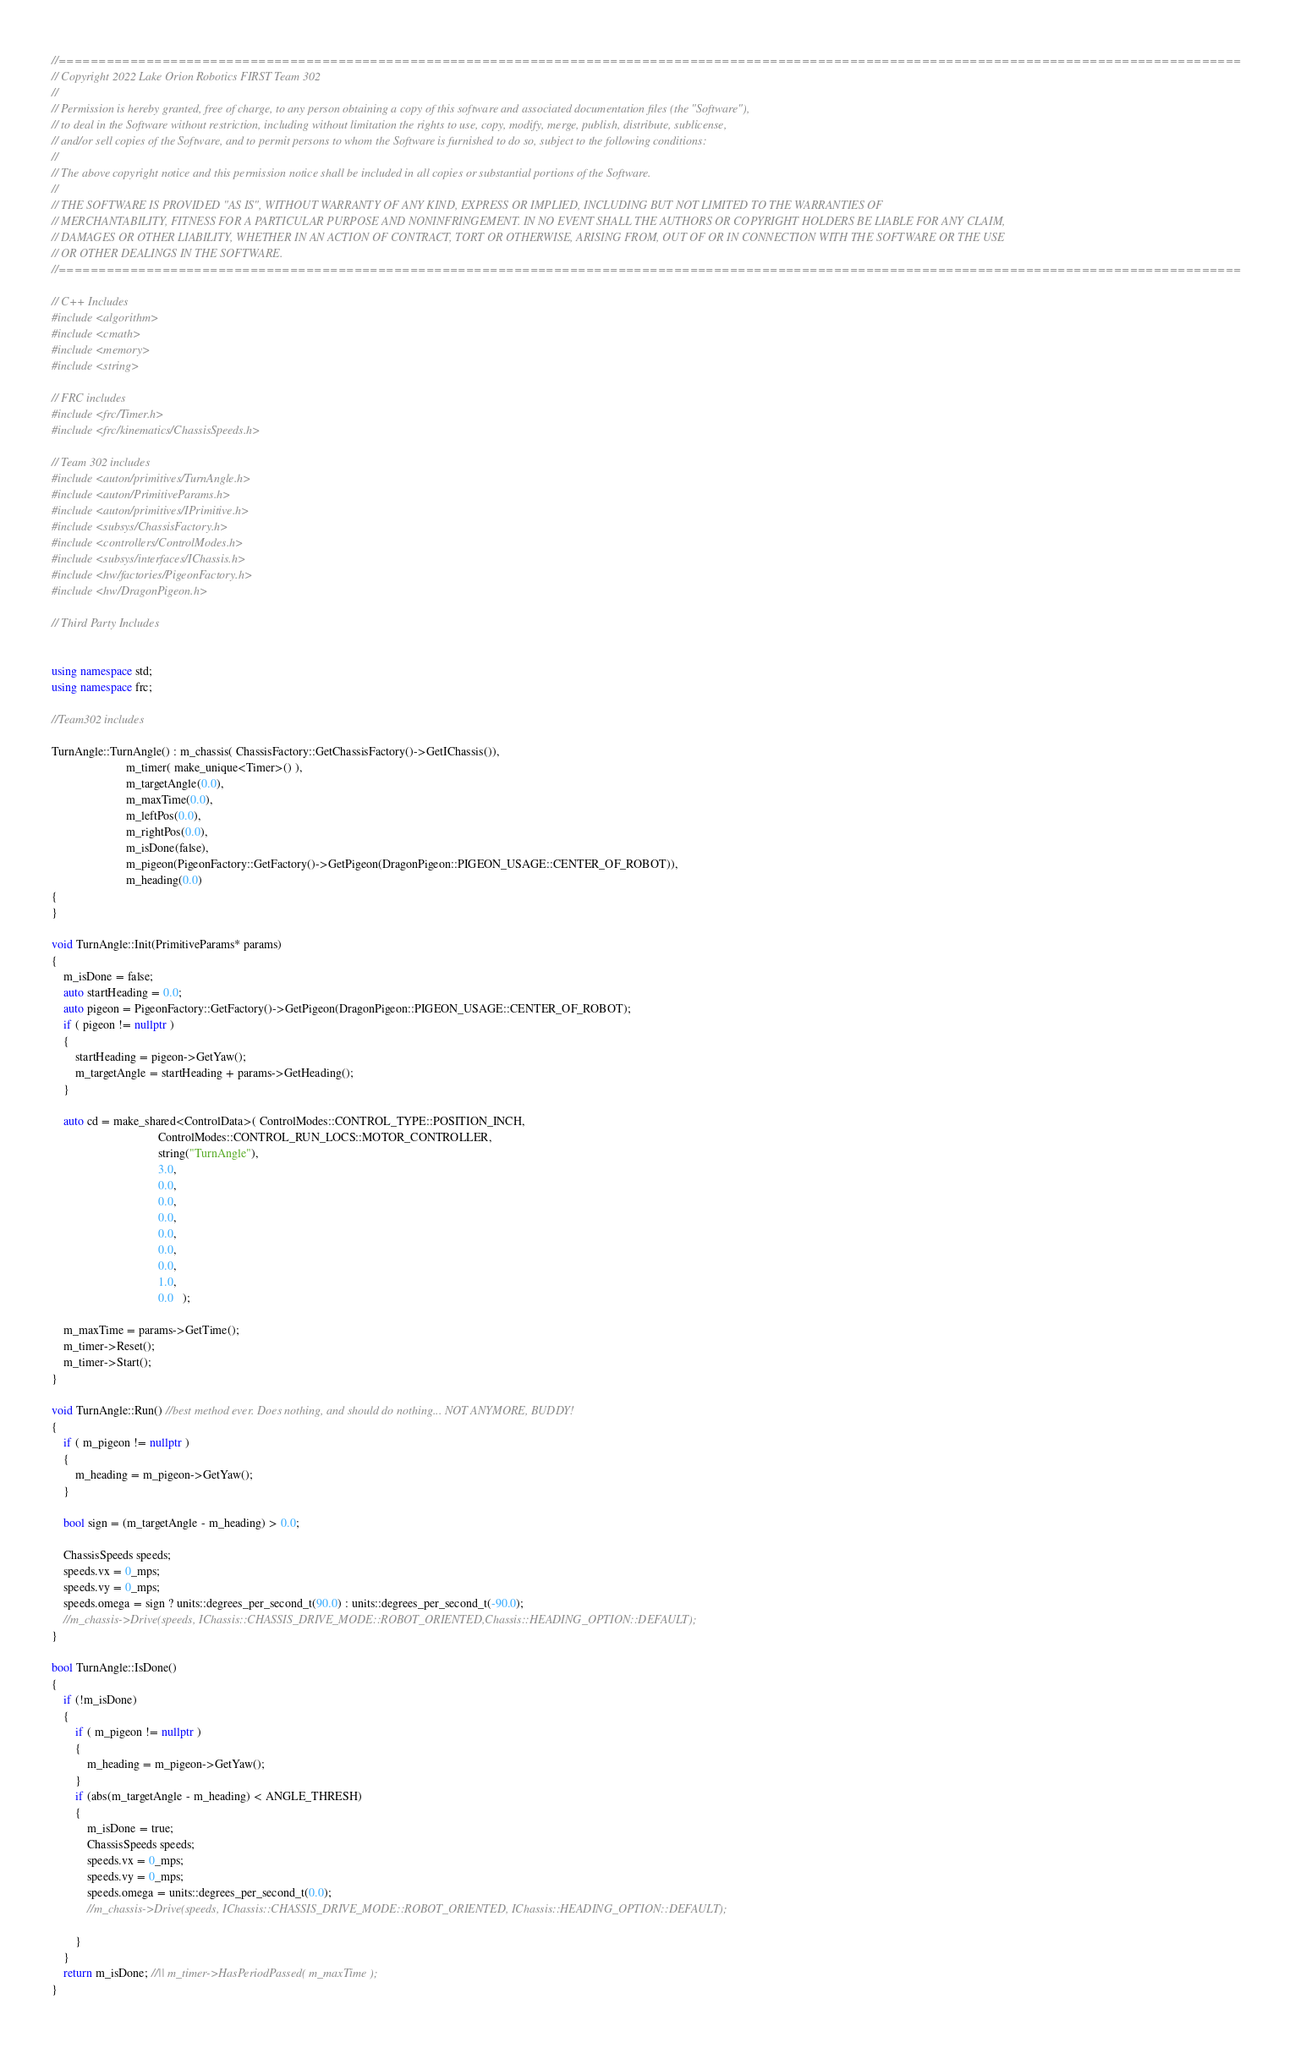Convert code to text. <code><loc_0><loc_0><loc_500><loc_500><_C++_>
//====================================================================================================================================================
// Copyright 2022 Lake Orion Robotics FIRST Team 302
//
// Permission is hereby granted, free of charge, to any person obtaining a copy of this software and associated documentation files (the "Software"),
// to deal in the Software without restriction, including without limitation the rights to use, copy, modify, merge, publish, distribute, sublicense,
// and/or sell copies of the Software, and to permit persons to whom the Software is furnished to do so, subject to the following conditions:
//
// The above copyright notice and this permission notice shall be included in all copies or substantial portions of the Software.
//
// THE SOFTWARE IS PROVIDED "AS IS", WITHOUT WARRANTY OF ANY KIND, EXPRESS OR IMPLIED, INCLUDING BUT NOT LIMITED TO THE WARRANTIES OF
// MERCHANTABILITY, FITNESS FOR A PARTICULAR PURPOSE AND NONINFRINGEMENT. IN NO EVENT SHALL THE AUTHORS OR COPYRIGHT HOLDERS BE LIABLE FOR ANY CLAIM,
// DAMAGES OR OTHER LIABILITY, WHETHER IN AN ACTION OF CONTRACT, TORT OR OTHERWISE, ARISING FROM, OUT OF OR IN CONNECTION WITH THE SOFTWARE OR THE USE
// OR OTHER DEALINGS IN THE SOFTWARE.
//====================================================================================================================================================

// C++ Includes
#include <algorithm>
#include <cmath>
#include <memory>
#include <string>

// FRC includes
#include <frc/Timer.h>
#include <frc/kinematics/ChassisSpeeds.h>

// Team 302 includes
#include <auton/primitives/TurnAngle.h>
#include <auton/PrimitiveParams.h>
#include <auton/primitives/IPrimitive.h>
#include <subsys/ChassisFactory.h>
#include <controllers/ControlModes.h>
#include <subsys/interfaces/IChassis.h>
#include <hw/factories/PigeonFactory.h>
#include <hw/DragonPigeon.h>

// Third Party Includes


using namespace std;
using namespace frc;

//Team302 includes

TurnAngle::TurnAngle() : m_chassis( ChassisFactory::GetChassisFactory()->GetIChassis()),
						 m_timer( make_unique<Timer>() ),
						 m_targetAngle(0.0),
						 m_maxTime(0.0),
						 m_leftPos(0.0),
						 m_rightPos(0.0),
						 m_isDone(false),
						 m_pigeon(PigeonFactory::GetFactory()->GetPigeon(DragonPigeon::PIGEON_USAGE::CENTER_OF_ROBOT)),
						 m_heading(0.0)
{
}

void TurnAngle::Init(PrimitiveParams* params) 
{
	m_isDone = false;
	auto startHeading = 0.0;
	auto pigeon = PigeonFactory::GetFactory()->GetPigeon(DragonPigeon::PIGEON_USAGE::CENTER_OF_ROBOT);
	if ( pigeon != nullptr )
	{
		startHeading = pigeon->GetYaw();
		m_targetAngle = startHeading + params->GetHeading();
	}

	auto cd = make_shared<ControlData>( ControlModes::CONTROL_TYPE::POSITION_INCH, 
									ControlModes::CONTROL_RUN_LOCS::MOTOR_CONTROLLER,
									string("TurnAngle"),
									3.0,
									0.0,
									0.0,
									0.0,
									0.0,
									0.0,
									0.0,
									1.0,
									0.0   );

	m_maxTime = params->GetTime();
	m_timer->Reset();
	m_timer->Start();
}

void TurnAngle::Run() //best method ever. Does nothing, and should do nothing... NOT ANYMORE, BUDDY!
{
	if ( m_pigeon != nullptr )
	{
		m_heading = m_pigeon->GetYaw();
	}

	bool sign = (m_targetAngle - m_heading) > 0.0;

	ChassisSpeeds speeds;
	speeds.vx = 0_mps;
	speeds.vy = 0_mps;
	speeds.omega = sign ? units::degrees_per_second_t(90.0) : units::degrees_per_second_t(-90.0);
	//m_chassis->Drive(speeds, IChassis::CHASSIS_DRIVE_MODE::ROBOT_ORIENTED,Chassis::HEADING_OPTION::DEFAULT);
}

bool TurnAngle::IsDone() 
{
	if (!m_isDone) 
	{
		if ( m_pigeon != nullptr )
		{
			m_heading = m_pigeon->GetYaw();
		}
		if (abs(m_targetAngle - m_heading) < ANGLE_THRESH) 
		{
			m_isDone = true;
			ChassisSpeeds speeds;
			speeds.vx = 0_mps;
			speeds.vy = 0_mps;
			speeds.omega = units::degrees_per_second_t(0.0);
			//m_chassis->Drive(speeds, IChassis::CHASSIS_DRIVE_MODE::ROBOT_ORIENTED, IChassis::HEADING_OPTION::DEFAULT);

		}
	}
	return m_isDone; //|| m_timer->HasPeriodPassed( m_maxTime );
}
</code> 